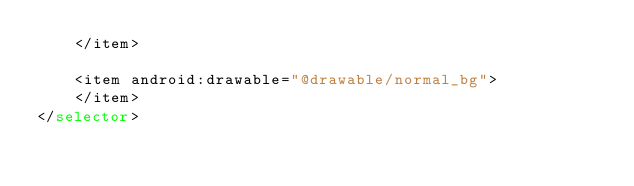<code> <loc_0><loc_0><loc_500><loc_500><_XML_>    </item>

    <item android:drawable="@drawable/normal_bg">
    </item>
</selector></code> 